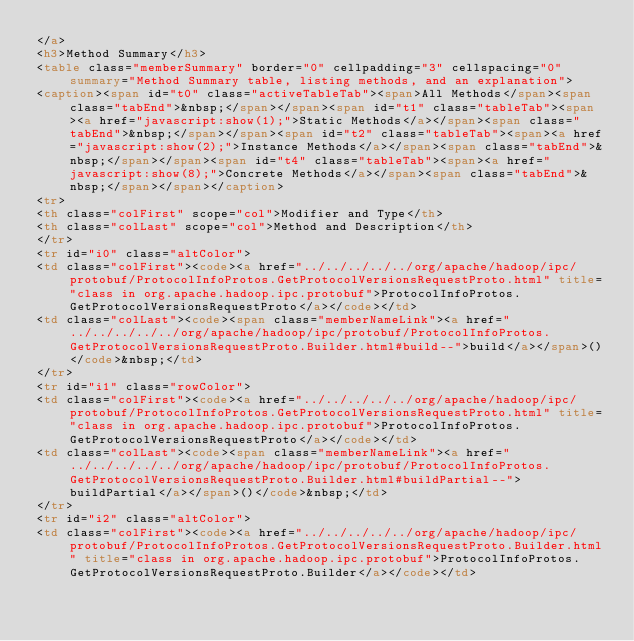Convert code to text. <code><loc_0><loc_0><loc_500><loc_500><_HTML_></a>
<h3>Method Summary</h3>
<table class="memberSummary" border="0" cellpadding="3" cellspacing="0" summary="Method Summary table, listing methods, and an explanation">
<caption><span id="t0" class="activeTableTab"><span>All Methods</span><span class="tabEnd">&nbsp;</span></span><span id="t1" class="tableTab"><span><a href="javascript:show(1);">Static Methods</a></span><span class="tabEnd">&nbsp;</span></span><span id="t2" class="tableTab"><span><a href="javascript:show(2);">Instance Methods</a></span><span class="tabEnd">&nbsp;</span></span><span id="t4" class="tableTab"><span><a href="javascript:show(8);">Concrete Methods</a></span><span class="tabEnd">&nbsp;</span></span></caption>
<tr>
<th class="colFirst" scope="col">Modifier and Type</th>
<th class="colLast" scope="col">Method and Description</th>
</tr>
<tr id="i0" class="altColor">
<td class="colFirst"><code><a href="../../../../../org/apache/hadoop/ipc/protobuf/ProtocolInfoProtos.GetProtocolVersionsRequestProto.html" title="class in org.apache.hadoop.ipc.protobuf">ProtocolInfoProtos.GetProtocolVersionsRequestProto</a></code></td>
<td class="colLast"><code><span class="memberNameLink"><a href="../../../../../org/apache/hadoop/ipc/protobuf/ProtocolInfoProtos.GetProtocolVersionsRequestProto.Builder.html#build--">build</a></span>()</code>&nbsp;</td>
</tr>
<tr id="i1" class="rowColor">
<td class="colFirst"><code><a href="../../../../../org/apache/hadoop/ipc/protobuf/ProtocolInfoProtos.GetProtocolVersionsRequestProto.html" title="class in org.apache.hadoop.ipc.protobuf">ProtocolInfoProtos.GetProtocolVersionsRequestProto</a></code></td>
<td class="colLast"><code><span class="memberNameLink"><a href="../../../../../org/apache/hadoop/ipc/protobuf/ProtocolInfoProtos.GetProtocolVersionsRequestProto.Builder.html#buildPartial--">buildPartial</a></span>()</code>&nbsp;</td>
</tr>
<tr id="i2" class="altColor">
<td class="colFirst"><code><a href="../../../../../org/apache/hadoop/ipc/protobuf/ProtocolInfoProtos.GetProtocolVersionsRequestProto.Builder.html" title="class in org.apache.hadoop.ipc.protobuf">ProtocolInfoProtos.GetProtocolVersionsRequestProto.Builder</a></code></td></code> 